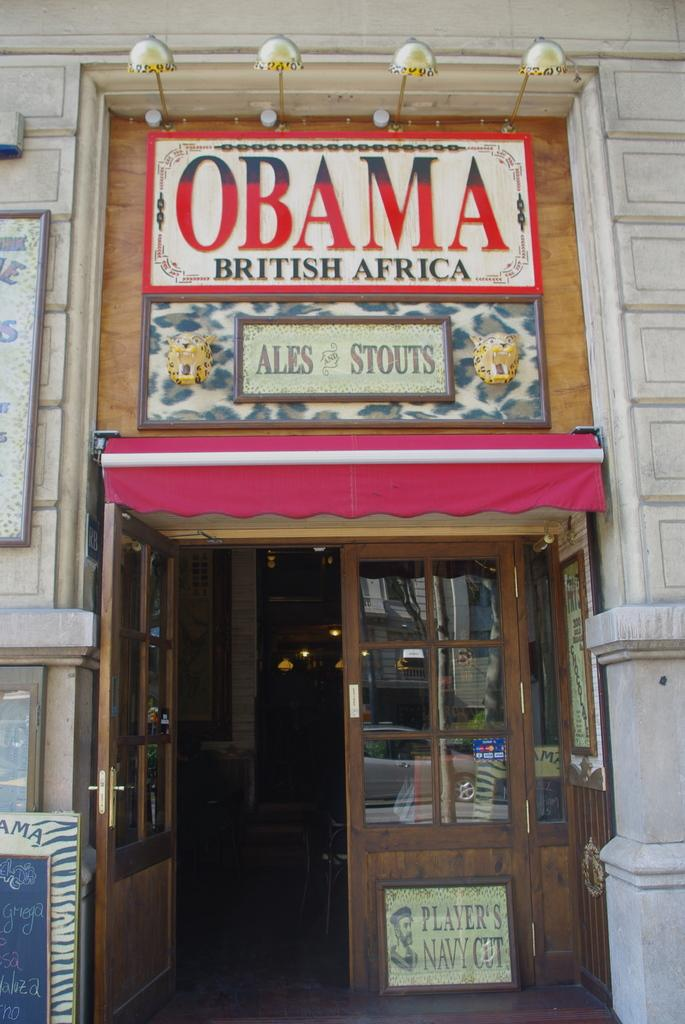What type of establishment is depicted in the image? There is a store in the image. Can you describe any specific features of the store? There are doors in the image, and there is writing on the store. What else can be seen in the image besides the store? There is a board in the image. How does the bear interact with the store in the image? There is no bear present in the image, so it cannot interact with the store. 